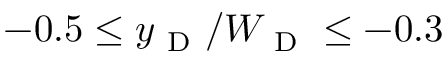Convert formula to latex. <formula><loc_0><loc_0><loc_500><loc_500>- 0 . 5 \leq y _ { D } / W _ { D } \leq - 0 . 3</formula> 